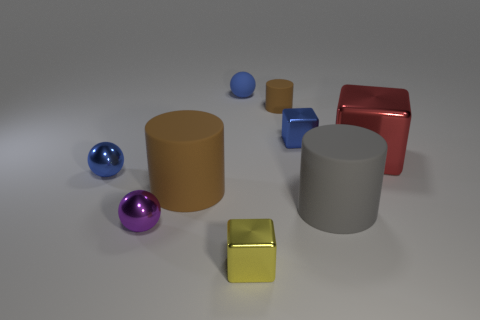How many things are large gray metal cylinders or tiny cubes on the left side of the tiny cylinder?
Your answer should be very brief. 1. What is the material of the thing that is the same color as the tiny cylinder?
Your answer should be compact. Rubber. There is a blue metallic object right of the yellow thing; is it the same size as the small yellow metallic cube?
Ensure brevity in your answer.  Yes. How many small cylinders are in front of the small blue metallic object to the left of the tiny metallic block in front of the purple object?
Make the answer very short. 0. How many blue objects are either matte objects or tiny shiny things?
Keep it short and to the point. 3. What is the color of the ball that is made of the same material as the tiny brown object?
Your answer should be compact. Blue. What number of tiny things are red blocks or cyan shiny balls?
Offer a very short reply. 0. Is the number of large cylinders less than the number of yellow metallic blocks?
Make the answer very short. No. What color is the small thing that is the same shape as the big gray object?
Provide a short and direct response. Brown. Are there more blue spheres than big purple metallic objects?
Your answer should be very brief. Yes. 